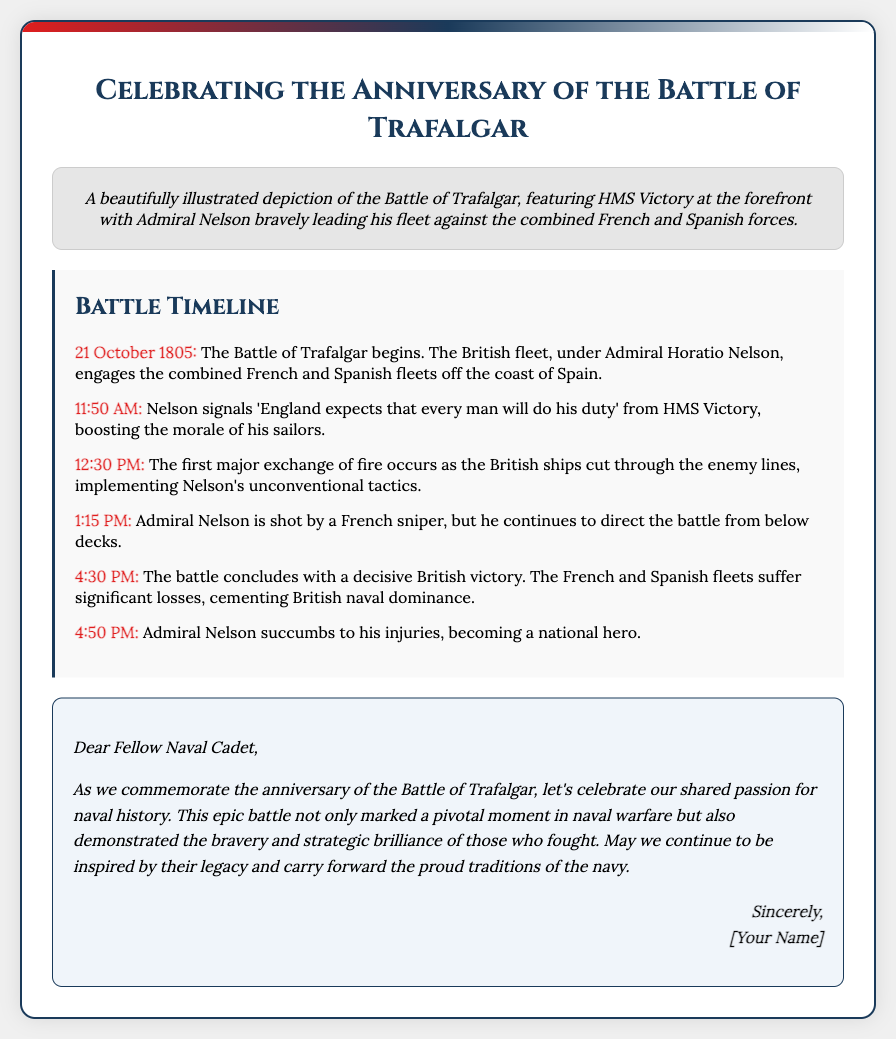What is the title of the card? The title is prominently displayed at the top of the card, stating its purpose and theme.
Answer: Celebrating the Anniversary of the Battle of Trafalgar Who leads the British fleet in the battle? The message and timeline detail the command structure during the battle, specifically naming the leader.
Answer: Admiral Horatio Nelson What significant quote did Nelson signal? The timeline includes one of the most famous signals made by Nelson during the battle, which is both motivational and historical.
Answer: England expects that every man will do his duty What date does the Battle of Trafalgar begin? The timeline provides the exact date when the battle commenced, which is a key historical detail.
Answer: 21 October 1805 At what time did Admiral Nelson succumb to his injuries? The timeline indicates the specific time when Nelson passed away, marking an important moment in the story of the battle.
Answer: 4:50 PM What was the outcome of the battle? The conclusion of the battle is summarized in the timeline, highlighting its significance in naval history.
Answer: Decisive British victory What type of illustration is featured on the card? The card's design includes a descriptive section about its visual representation, which adds thematic value.
Answer: A beautifully illustrated depiction of the Battle of Trafalgar What is emphasized in the heartfelt message? The message's content focuses on a specific aspect that bonds the sender and recipient through their interests.
Answer: Shared passion for naval history 